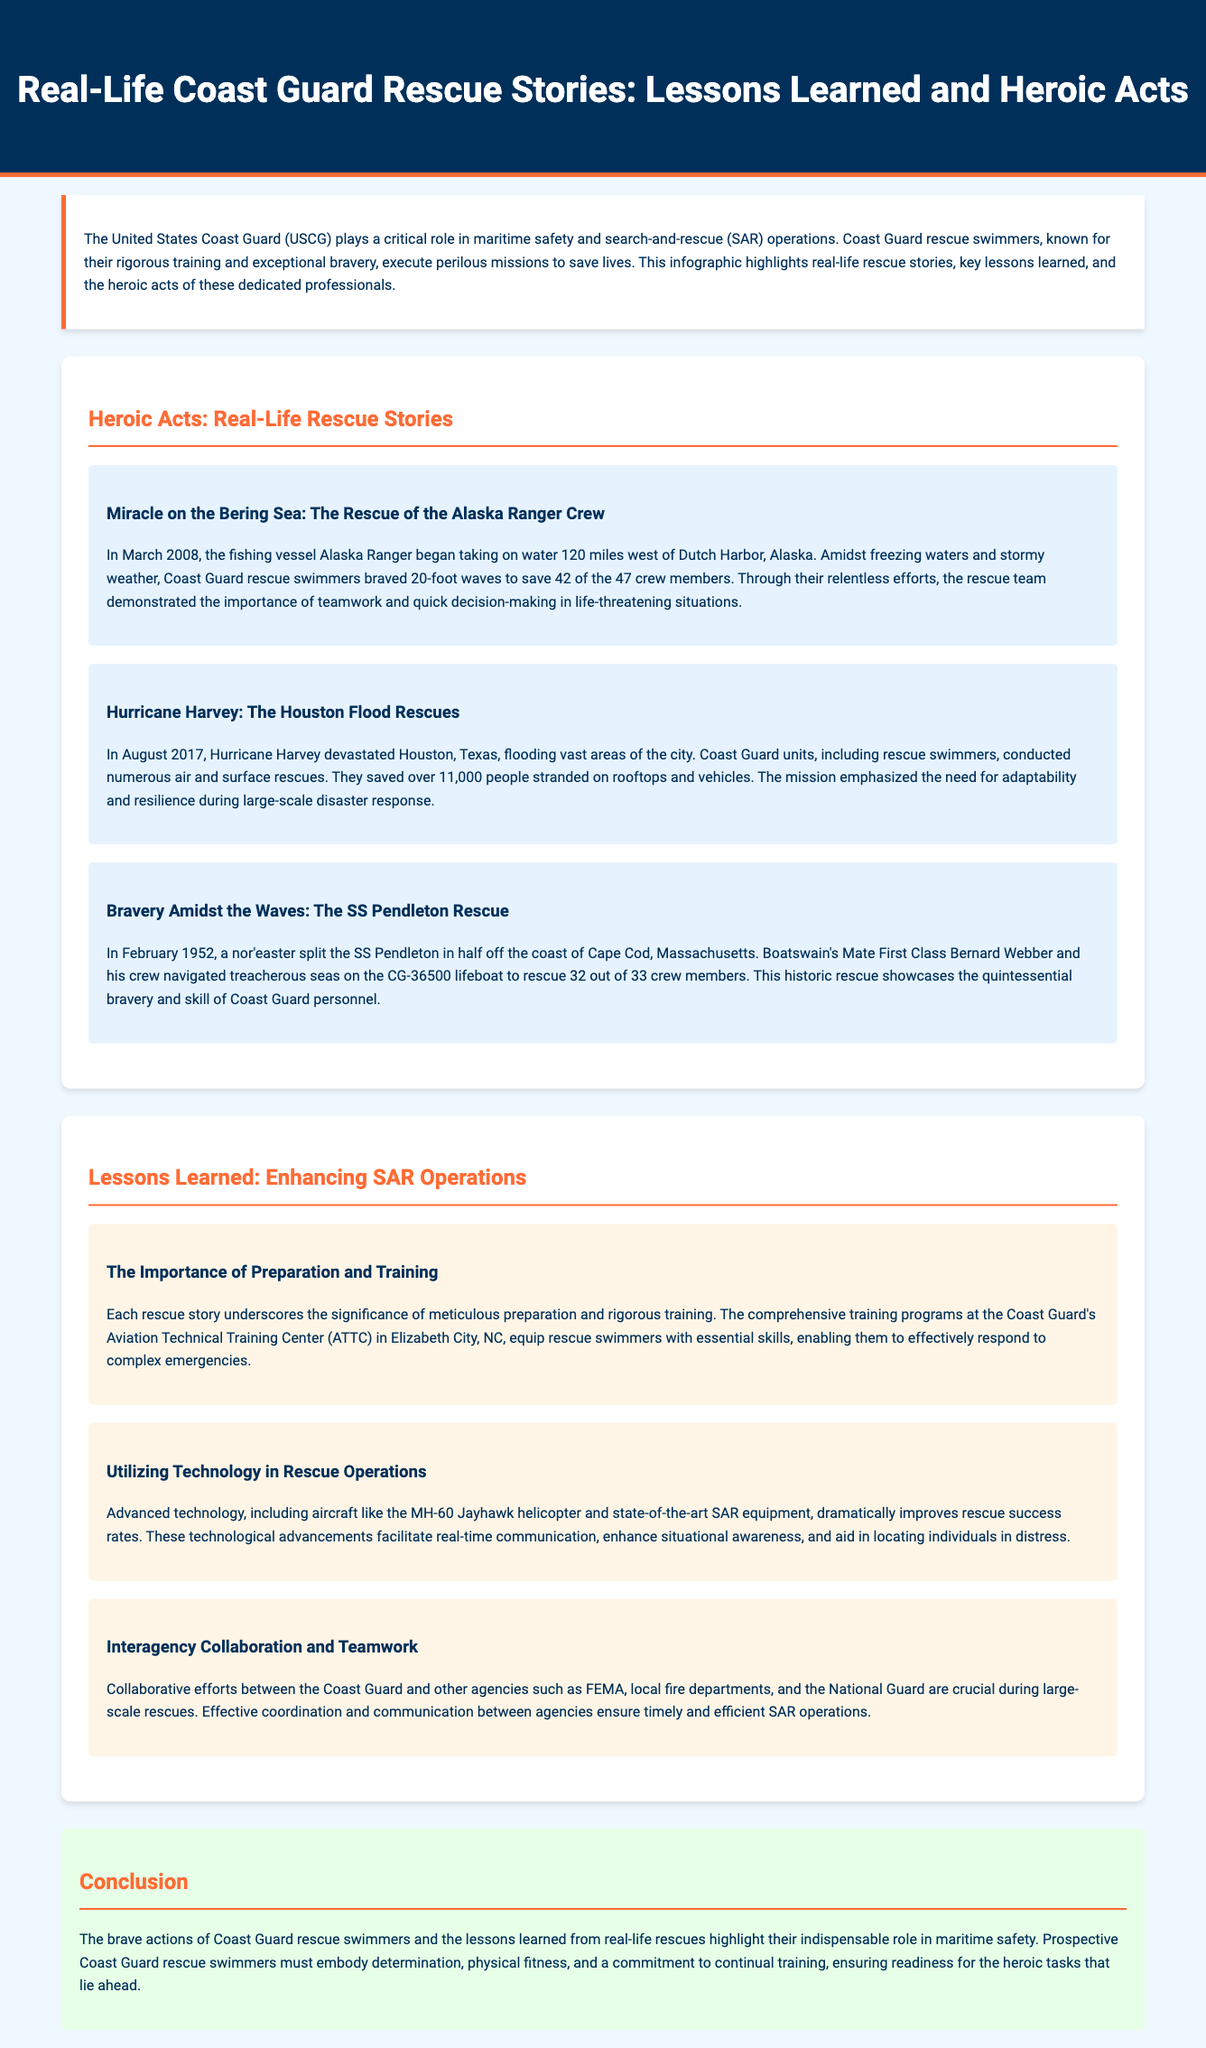What year did the Alaska Ranger rescue occur? The rescue of the Alaska Ranger crew took place in March 2008, as stated in the rescue story.
Answer: 2008 How many crew members were rescued from the Alaska Ranger? The document indicates that 42 out of 47 crew members were rescued during the operation.
Answer: 42 What was the significant weather event during the Hurricane Harvey rescues? The rescues took place during Hurricane Harvey, which devastated Houston in August 2017, emphasizing the severe flooding.
Answer: Hurricane Harvey Who was the Boatswain's Mate involved in the SS Pendleton rescue? The document states that Boatswain's Mate First Class Bernard Webber and his crew were crucial to the rescue of the SS Pendleton crew members.
Answer: Bernard Webber What is one key lesson learned from the rescue stories? The importance of preparation and training is highlighted as a key lesson that enhances search-and-rescue operations.
Answer: Preparation and training What type of technology has improved rescue success rates? The document mentions advanced technology such as the MH-60 Jayhawk helicopter as a significant factor in improving rescue success rates.
Answer: MH-60 Jayhawk helicopter How many people were rescued during the Hurricane Harvey operation? The Coast Guard teams rescued over 11,000 people stranded due to flooding during the Hurricane Harvey disaster response.
Answer: 11,000 What is a crucial aspect of interagency collaboration according to the document? Effective coordination and communication between different agencies, such as FEMA and local fire departments, are emphasized as crucial during rescues.
Answer: Coordination and communication What color is used for the main background of the document? The primary background color of the infographic page is a light blue shade (#f0f8ff) described in the styling section.
Answer: Light blue 